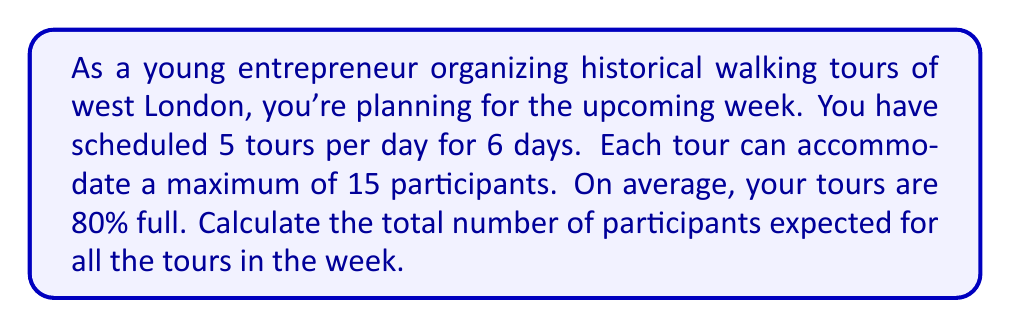Solve this math problem. Let's break this problem down step by step:

1. Calculate the total number of tours for the week:
   $$ \text{Tours per day} \times \text{Number of days} = 5 \times 6 = 30 \text{ tours} $$

2. Calculate the maximum capacity for all tours:
   $$ \text{Total tours} \times \text{Maximum participants per tour} = 30 \times 15 = 450 \text{ participants} $$

3. Calculate the expected number of participants based on the average occupancy:
   $$ \text{Maximum capacity} \times \text{Average occupancy} = 450 \times 0.80 = 360 \text{ participants} $$

Therefore, the expected number of participants for all tours in the week is 360.
Answer: 360 participants 